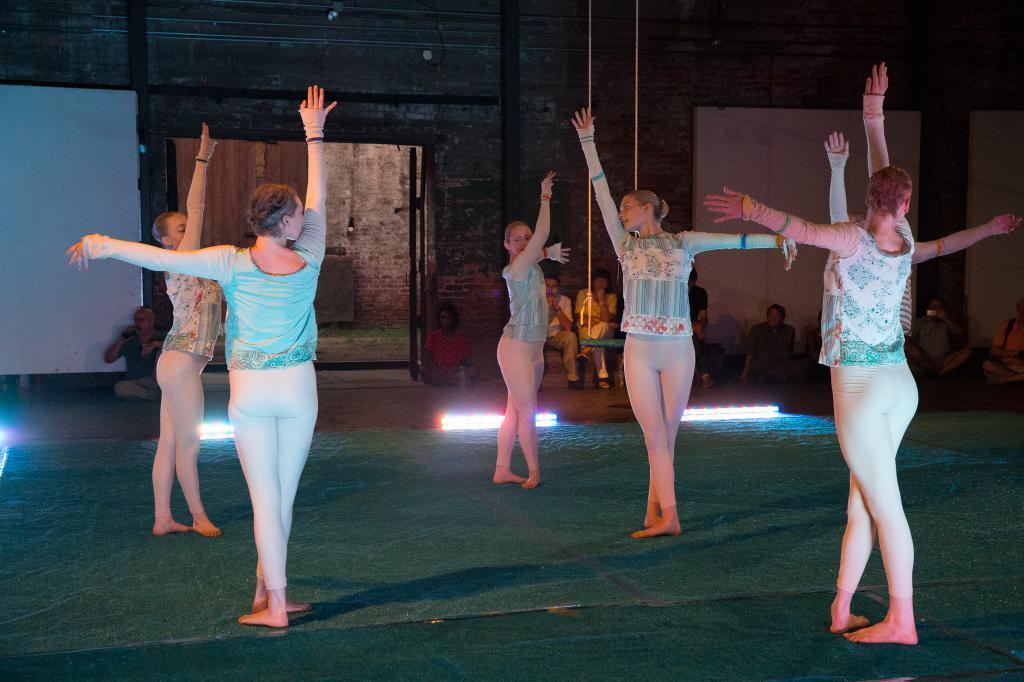In one or two sentences, can you explain what this image depicts? In the picture I can see five women wearing blue color tops and white color pants are standing on the ground. In the background, I can see few people are sitting, I can see white color boards, some wires and the wall. 